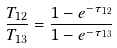<formula> <loc_0><loc_0><loc_500><loc_500>\frac { T _ { 1 2 } } { T _ { 1 3 } } = \frac { 1 - e ^ { - \tau _ { 1 2 } } } { 1 - e ^ { - \tau _ { 1 3 } } }</formula> 